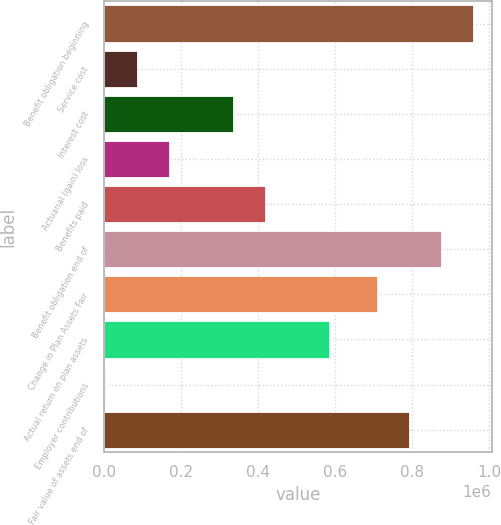<chart> <loc_0><loc_0><loc_500><loc_500><bar_chart><fcel>Benefit obligation beginning<fcel>Service cost<fcel>Interest cost<fcel>Actuarial (gain) loss<fcel>Benefits paid<fcel>Benefit obligation end of<fcel>Change in Plan Assets Fair<fcel>Actual return on plan assets<fcel>Employer contributions<fcel>Fair value of assets end of<nl><fcel>959030<fcel>87022.2<fcel>335675<fcel>169906<fcel>418559<fcel>876145<fcel>710377<fcel>584327<fcel>4138<fcel>793261<nl></chart> 